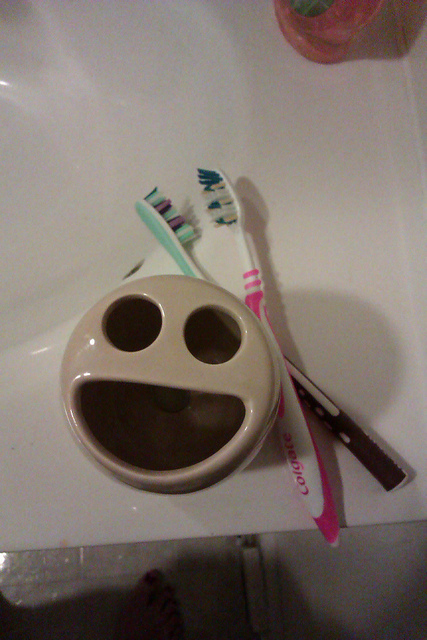Identify the text displayed in this image. Colgate 